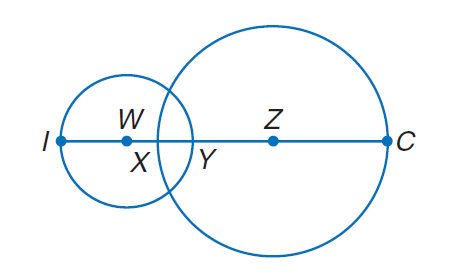Question: Circle W has a radius of 4 units, \odot Z has a radius of 7 units, and X Y = 2. Find I C.
Choices:
A. 5
B. 10
C. 15
D. 20
Answer with the letter. Answer: D Question: Circle W has a radius of 4 units, \odot Z has a radius of 7 units, and X Y = 2. Find Y Z.
Choices:
A. 5
B. 10
C. 15
D. 20
Answer with the letter. Answer: A 